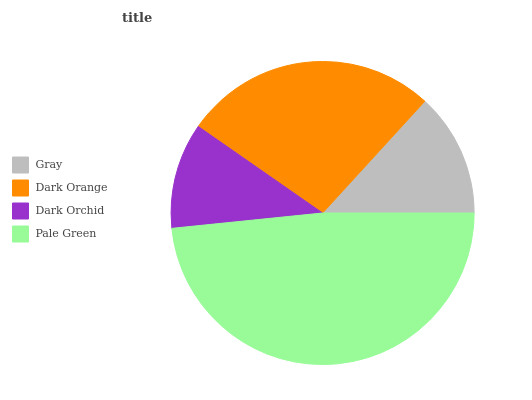Is Dark Orchid the minimum?
Answer yes or no. Yes. Is Pale Green the maximum?
Answer yes or no. Yes. Is Dark Orange the minimum?
Answer yes or no. No. Is Dark Orange the maximum?
Answer yes or no. No. Is Dark Orange greater than Gray?
Answer yes or no. Yes. Is Gray less than Dark Orange?
Answer yes or no. Yes. Is Gray greater than Dark Orange?
Answer yes or no. No. Is Dark Orange less than Gray?
Answer yes or no. No. Is Dark Orange the high median?
Answer yes or no. Yes. Is Gray the low median?
Answer yes or no. Yes. Is Pale Green the high median?
Answer yes or no. No. Is Dark Orchid the low median?
Answer yes or no. No. 